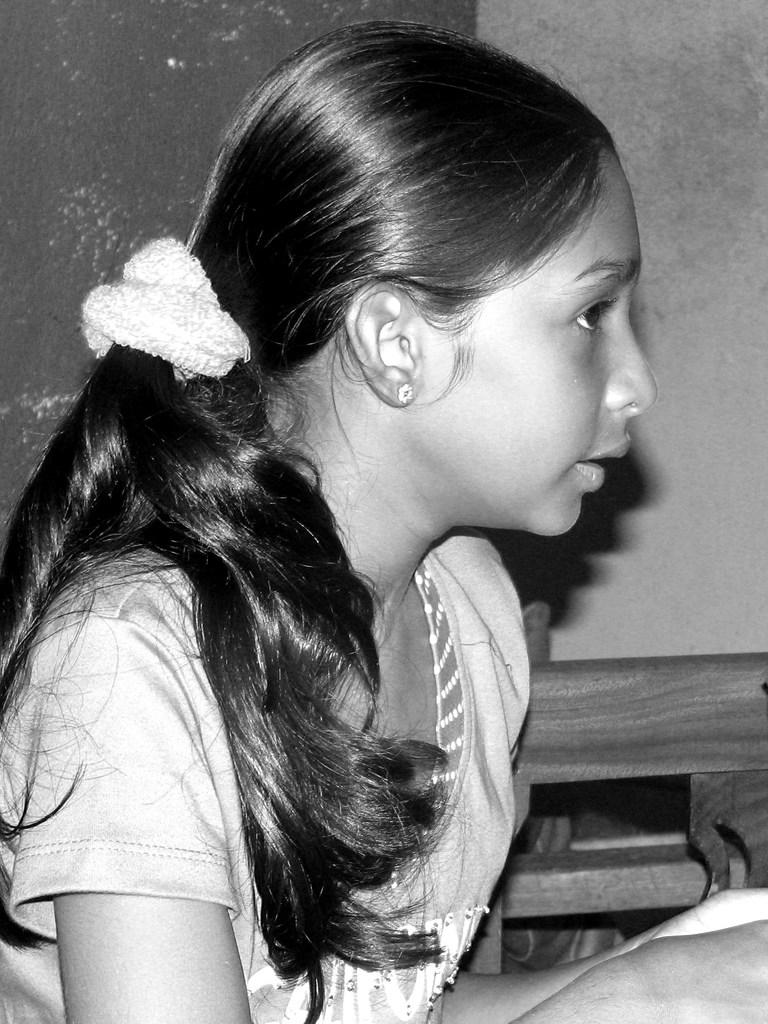What is the color scheme of the image? The image is black and white. Can you describe the main subject in the image? There is a person in the image. What can be seen in the background of the image? There is a wall and a wooden object in the background of the image. Are there any other objects visible in the background? Yes, there is an unspecified object in the background of the image. What type of smell can be detected in the image? There is no information about smells in the image, as it is a visual medium. --- Facts: 1. There is a car in the image. 2. The car is red. 3. The car has four wheels. 4. There is a road in the image. 5. The road is paved. Absurd Topics: bird, ocean, mountain Conversation: What is the main subject of the image? The main subject of the image is a car. Can you describe the car's appearance? The car is red and has four wheels. What can be seen in the background of the image? There is a road in the image. How is the road constructed? The road is paved. Reasoning: Let's think step by step in order to produce the conversation. We start by identifying the main subject of the image, which is a car. Then, we describe the car's appearance, mentioning its color and the number of wheels. Next, we describe the background, mentioning the road. Finally, we provide information about the road's construction. Absurd Question/Answer: How many birds can be seen flying over the car in the image? There are no birds visible in the image. 